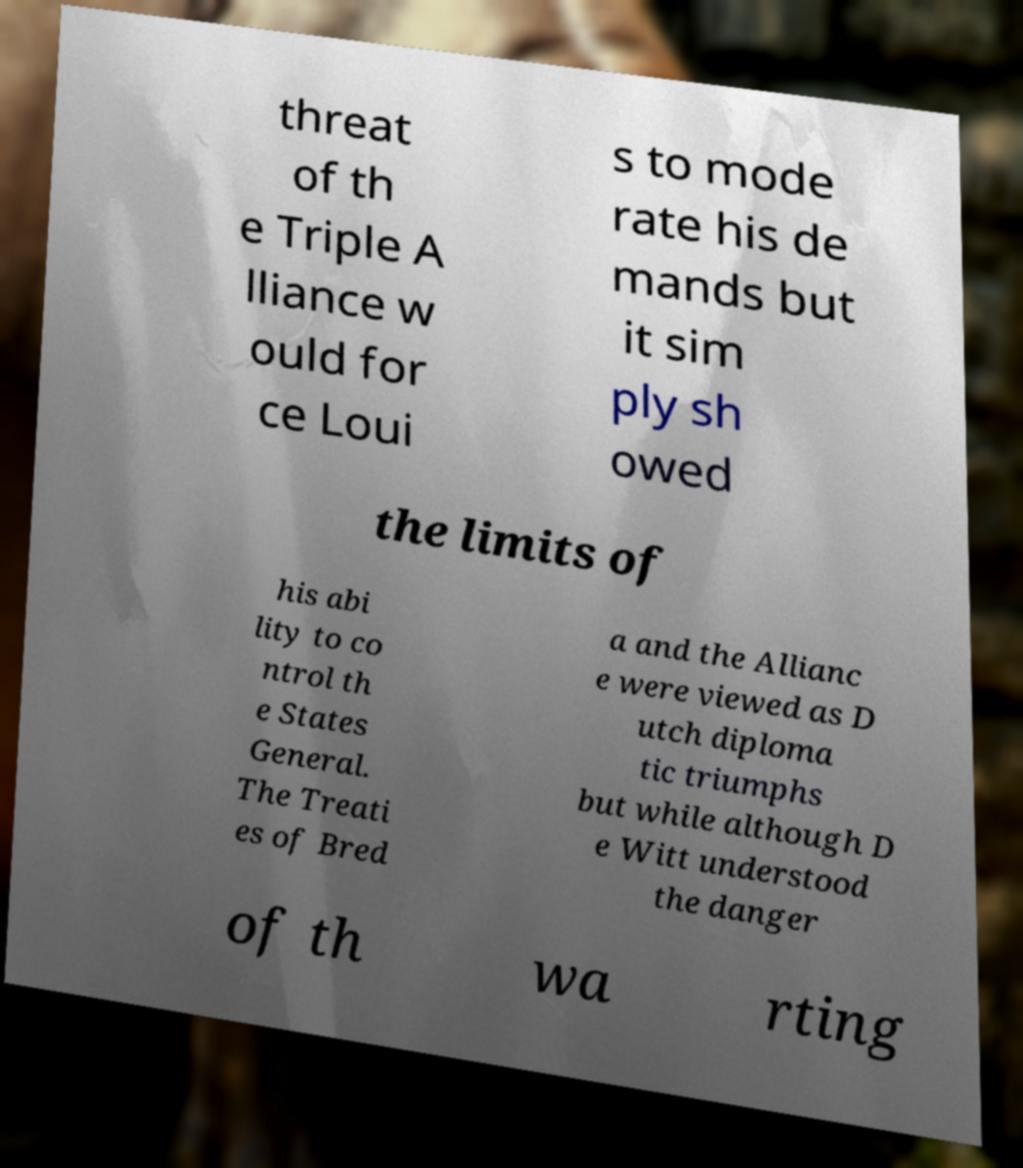Please read and relay the text visible in this image. What does it say? threat of th e Triple A lliance w ould for ce Loui s to mode rate his de mands but it sim ply sh owed the limits of his abi lity to co ntrol th e States General. The Treati es of Bred a and the Allianc e were viewed as D utch diploma tic triumphs but while although D e Witt understood the danger of th wa rting 